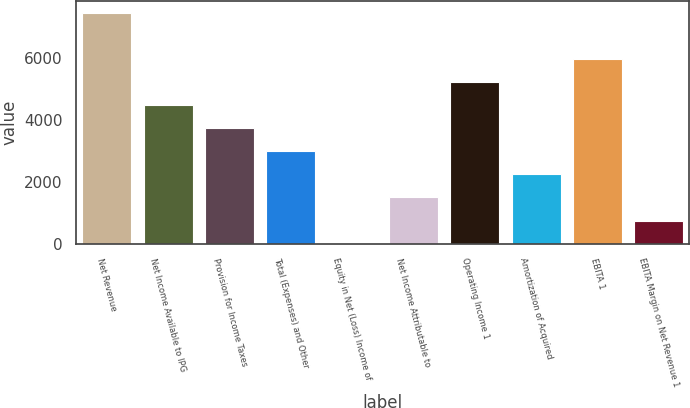Convert chart. <chart><loc_0><loc_0><loc_500><loc_500><bar_chart><fcel>Net Revenue<fcel>Net Income Available to IPG<fcel>Provision for Income Taxes<fcel>Total (Expenses) and Other<fcel>Equity in Net (Loss) Income of<fcel>Net Income Attributable to<fcel>Operating Income 1<fcel>Amortization of Acquired<fcel>EBITA 1<fcel>EBITA Margin on Net Revenue 1<nl><fcel>7473.5<fcel>4484.46<fcel>3737.2<fcel>2989.94<fcel>0.9<fcel>1495.42<fcel>5231.72<fcel>2242.68<fcel>5978.98<fcel>748.16<nl></chart> 